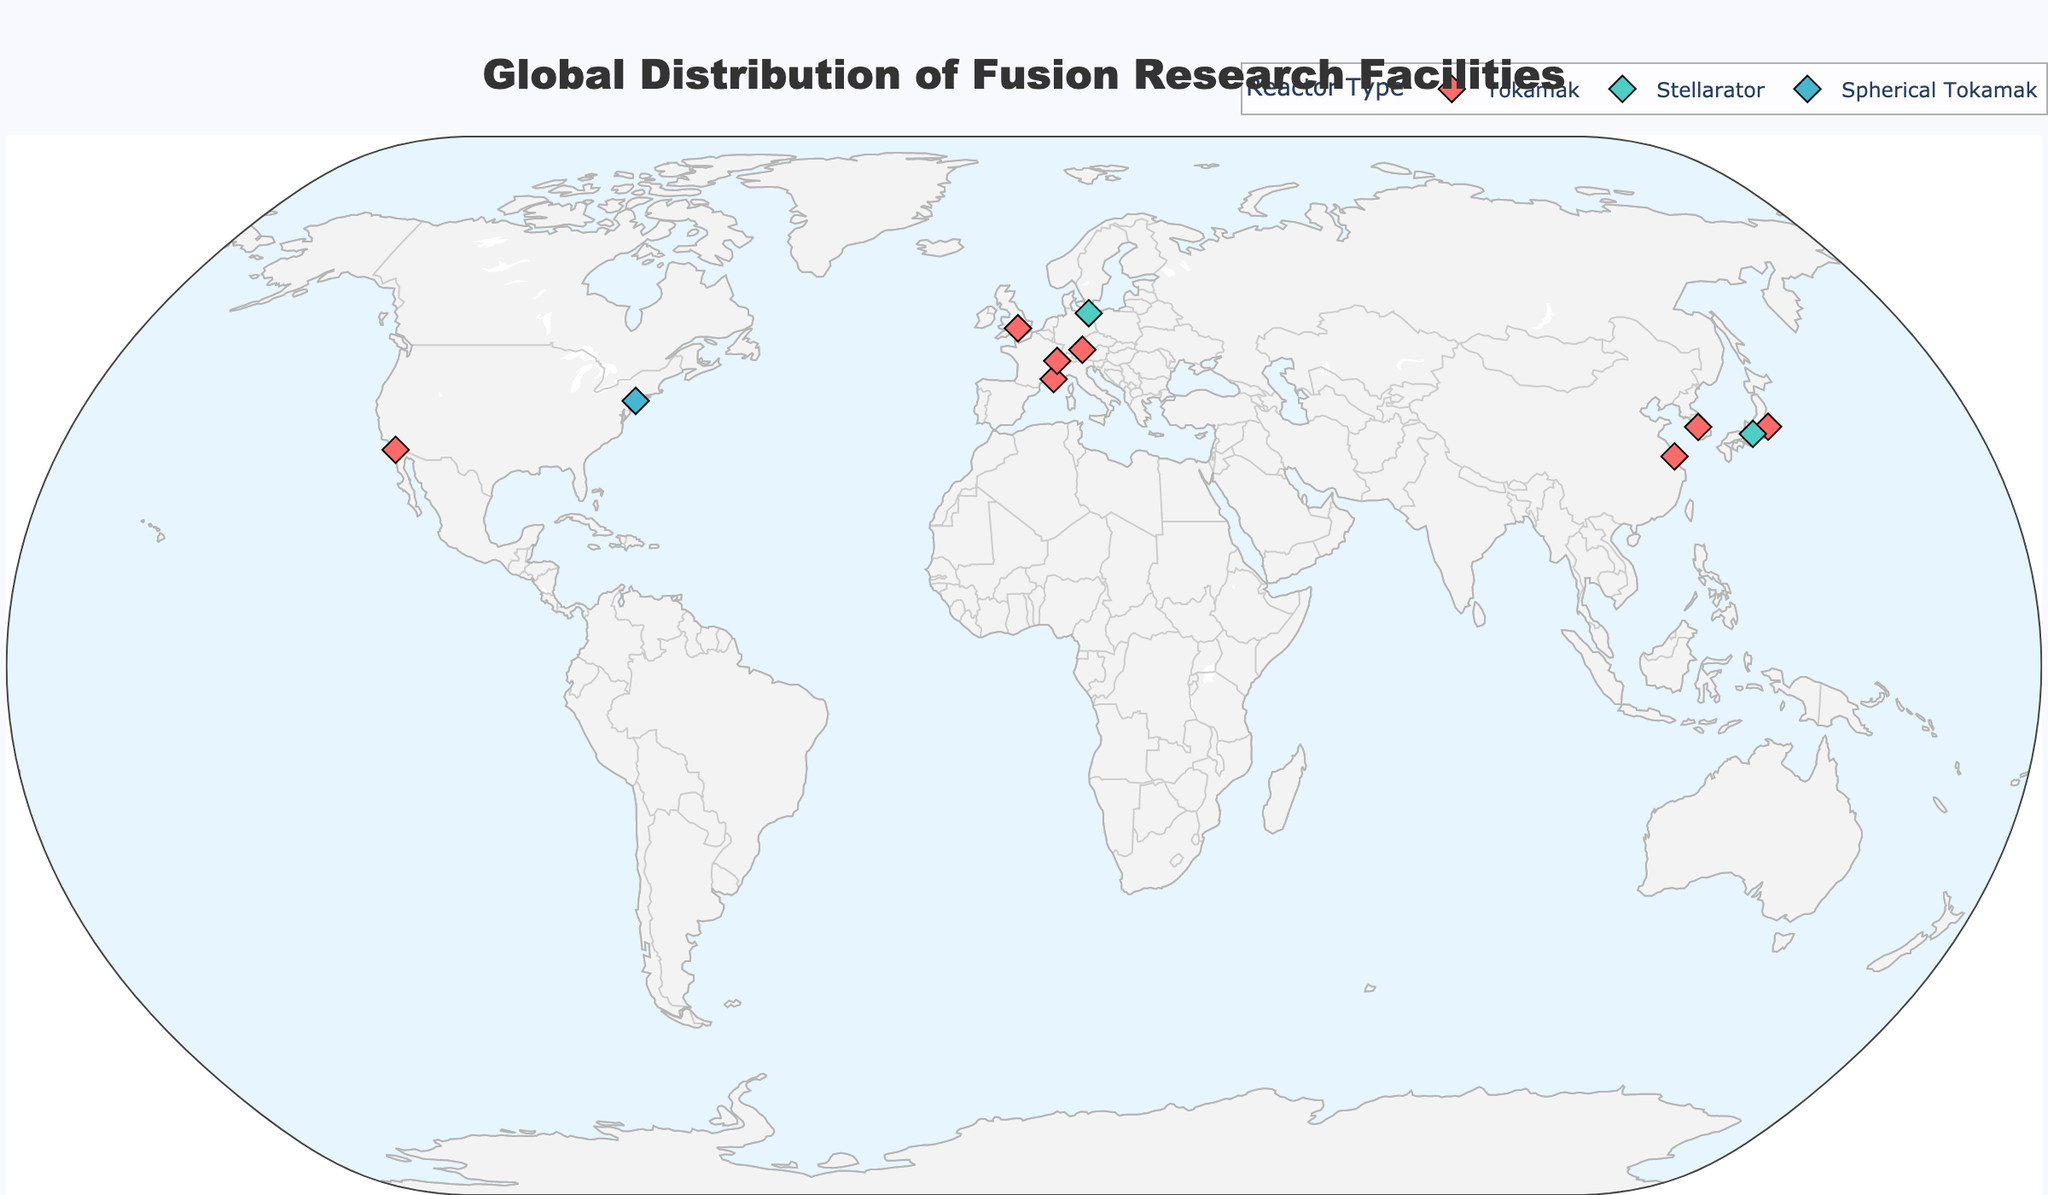Which country hosts the ITER facility? The ITER facility is hosted in France; this can be identified from the label on the geographic plot showing the location and associated text.
Answer: France What are the colors used to represent the Tokamak reactors on the plot? The plot's legend indicates that the color used to represent Tokamak reactors is a specific shade of red.
Answer: Red How many fusion research facilities are in Germany, and what types of reactors do they have? By observing the geographic markers on the plot in Germany, there are two fusion research facilities labeled "Wendelstein 7-X" and "ASDEX Upgrade," with the associated reactor types being Stellarator and Tokamak respectively.
Answer: Two; Stellarator and Tokamak Which facility is the farthest north, and what type of reactor does it have? The Wendelstein 7-X facility in Germany is the farthest north on the geographic plot. The associated marker shows that it has a Stellarator reactor.
Answer: Wendelstein 7-X; Stellarator What unique research is conducted at the KSTAR facility in South Korea? The marker for the KSTAR facility indicates that it conducts research on superconducting magnets. This can be seen from the hover text information in the plot.
Answer: Superconducting magnets research How does the number of facilities with Tokamak reactors compare to Stellarator reactors? By counting the marker representation of each reactor type on the geographic plot and referring to the legend, the number of Tokamak facilities is higher than Stellarator facilities.
Answer: More Tokamak facilities than Stellarator Which Tokamak facility has the highest latitude, and where is it located? Among the Tokamak facilities labeled on the plot, JET in the United Kingdom has the highest latitude amongst them.
Answer: JET; United Kingdom How many countries are represented by at least one fusion research facility? By observing the distribution of the facilities across the countries on the plot, a count of the unique countries represented by at least one facility can be determined. There are eight countries represented (France, United Kingdom, USA, Germany, South Korea, China, Japan, and Switzerland).
Answer: Eight Is there a country that has more than one type of fusion reactor? Analyzing the markers on the geographic plot for each country, Germany has both Tokamak (ASDEX Upgrade) and Stellarator (Wendelstein 7-X) reactors.
Answer: Yes, Germany 